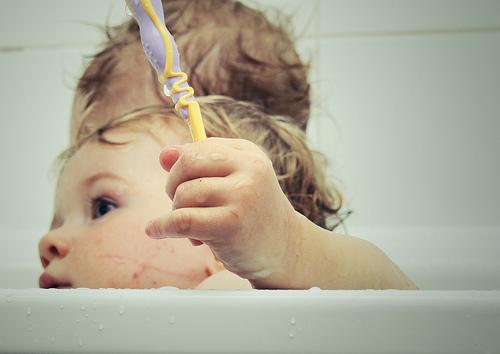How is the child in tub?
Quick response, please. 2. How many children are in the picture?
Short answer required. 2. What is this child holding?
Concise answer only. Toothbrush. 